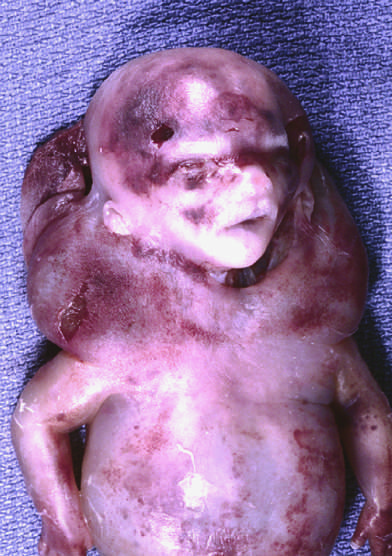re cystic hygromas characteristically seen with, but not limited to, constitutional chromosomal anomalies such as 45, x karyotypes?
Answer the question using a single word or phrase. Yes 